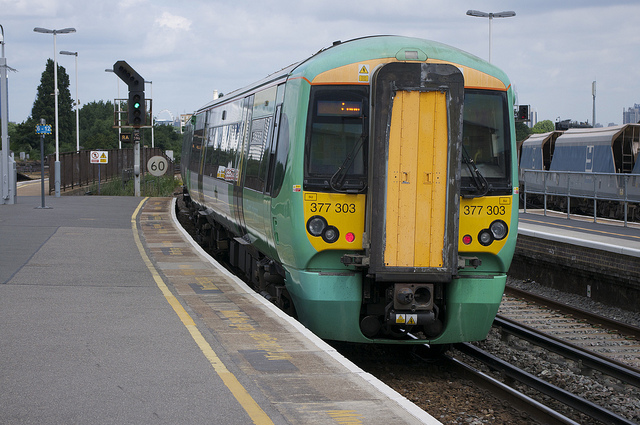Please extract the text content from this image. 377 303 377 303 60 RA 